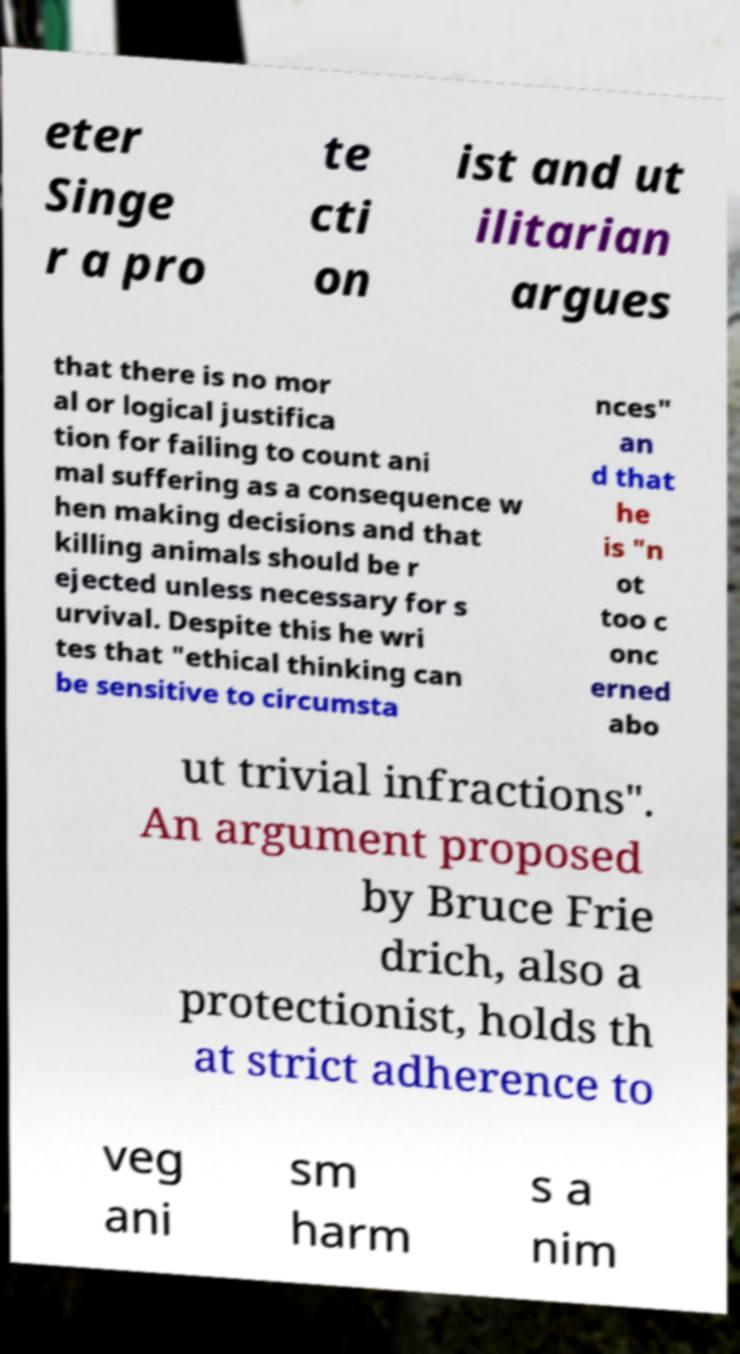Please identify and transcribe the text found in this image. eter Singe r a pro te cti on ist and ut ilitarian argues that there is no mor al or logical justifica tion for failing to count ani mal suffering as a consequence w hen making decisions and that killing animals should be r ejected unless necessary for s urvival. Despite this he wri tes that "ethical thinking can be sensitive to circumsta nces" an d that he is "n ot too c onc erned abo ut trivial infractions". An argument proposed by Bruce Frie drich, also a protectionist, holds th at strict adherence to veg ani sm harm s a nim 